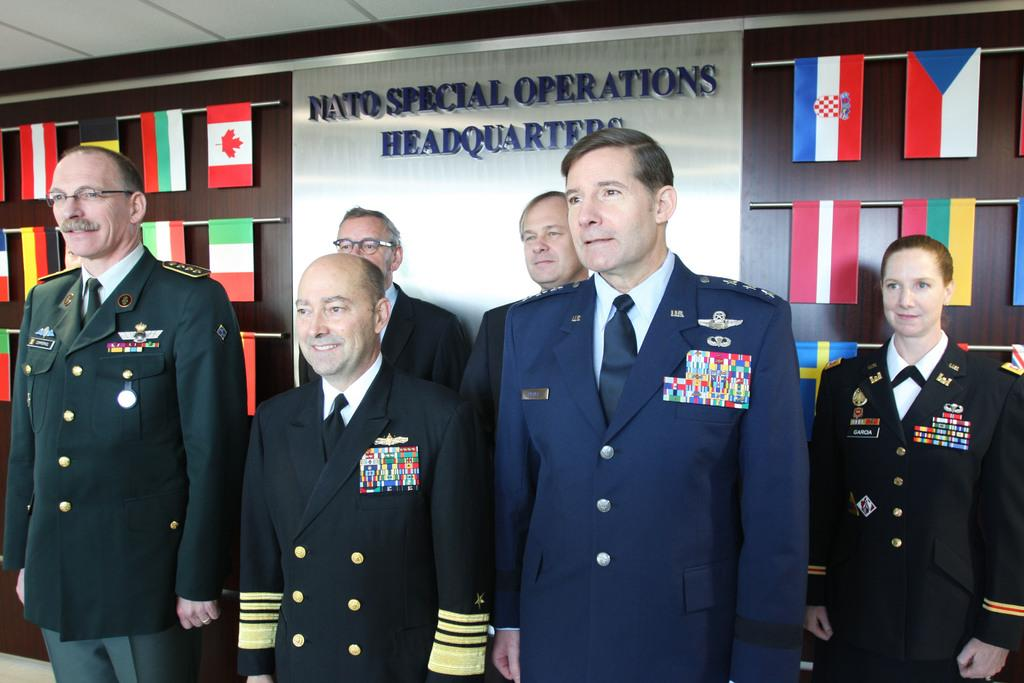What are the persons in the image wearing? The persons in the image are wearing uniforms. What are the persons in the image doing? The persons are standing. What can be seen in the background of the image? There is a brown colored surface and flags in the background of the image. What part of the room is visible in the background of the image? The ceiling is visible in the background of the image. What type of beef is being served at the government meeting in the image? There is no beef or government meeting present in the image. Who is the creator of the uniforms worn by the persons in the image? The facts provided do not mention the creator of the uniforms. 